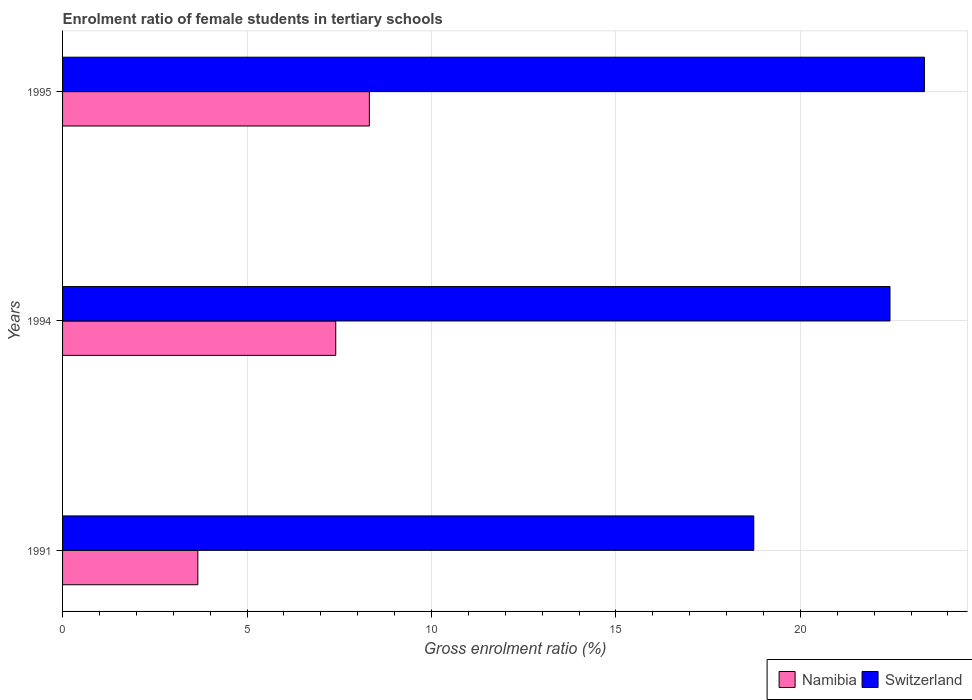How many different coloured bars are there?
Your answer should be very brief. 2. Are the number of bars per tick equal to the number of legend labels?
Your response must be concise. Yes. How many bars are there on the 3rd tick from the top?
Provide a succinct answer. 2. What is the enrolment ratio of female students in tertiary schools in Namibia in 1994?
Keep it short and to the point. 7.41. Across all years, what is the maximum enrolment ratio of female students in tertiary schools in Namibia?
Offer a terse response. 8.32. Across all years, what is the minimum enrolment ratio of female students in tertiary schools in Switzerland?
Your response must be concise. 18.74. What is the total enrolment ratio of female students in tertiary schools in Switzerland in the graph?
Provide a succinct answer. 64.53. What is the difference between the enrolment ratio of female students in tertiary schools in Switzerland in 1991 and that in 1994?
Make the answer very short. -3.69. What is the difference between the enrolment ratio of female students in tertiary schools in Switzerland in 1994 and the enrolment ratio of female students in tertiary schools in Namibia in 1995?
Make the answer very short. 14.11. What is the average enrolment ratio of female students in tertiary schools in Namibia per year?
Offer a terse response. 6.46. In the year 1991, what is the difference between the enrolment ratio of female students in tertiary schools in Namibia and enrolment ratio of female students in tertiary schools in Switzerland?
Your answer should be compact. -15.07. In how many years, is the enrolment ratio of female students in tertiary schools in Switzerland greater than 18 %?
Offer a terse response. 3. What is the ratio of the enrolment ratio of female students in tertiary schools in Namibia in 1991 to that in 1995?
Offer a terse response. 0.44. Is the difference between the enrolment ratio of female students in tertiary schools in Namibia in 1991 and 1995 greater than the difference between the enrolment ratio of female students in tertiary schools in Switzerland in 1991 and 1995?
Provide a short and direct response. No. What is the difference between the highest and the second highest enrolment ratio of female students in tertiary schools in Switzerland?
Give a very brief answer. 0.93. What is the difference between the highest and the lowest enrolment ratio of female students in tertiary schools in Switzerland?
Make the answer very short. 4.62. What does the 1st bar from the top in 1995 represents?
Keep it short and to the point. Switzerland. What does the 2nd bar from the bottom in 1991 represents?
Your answer should be very brief. Switzerland. How many bars are there?
Your answer should be compact. 6. How many years are there in the graph?
Your response must be concise. 3. Does the graph contain any zero values?
Offer a very short reply. No. Where does the legend appear in the graph?
Provide a succinct answer. Bottom right. How many legend labels are there?
Give a very brief answer. 2. What is the title of the graph?
Offer a terse response. Enrolment ratio of female students in tertiary schools. Does "Norway" appear as one of the legend labels in the graph?
Provide a succinct answer. No. What is the label or title of the Y-axis?
Your answer should be compact. Years. What is the Gross enrolment ratio (%) of Namibia in 1991?
Provide a short and direct response. 3.67. What is the Gross enrolment ratio (%) of Switzerland in 1991?
Your answer should be compact. 18.74. What is the Gross enrolment ratio (%) of Namibia in 1994?
Provide a short and direct response. 7.41. What is the Gross enrolment ratio (%) in Switzerland in 1994?
Your answer should be very brief. 22.43. What is the Gross enrolment ratio (%) in Namibia in 1995?
Keep it short and to the point. 8.32. What is the Gross enrolment ratio (%) of Switzerland in 1995?
Provide a succinct answer. 23.36. Across all years, what is the maximum Gross enrolment ratio (%) of Namibia?
Keep it short and to the point. 8.32. Across all years, what is the maximum Gross enrolment ratio (%) of Switzerland?
Give a very brief answer. 23.36. Across all years, what is the minimum Gross enrolment ratio (%) of Namibia?
Your answer should be compact. 3.67. Across all years, what is the minimum Gross enrolment ratio (%) in Switzerland?
Give a very brief answer. 18.74. What is the total Gross enrolment ratio (%) in Namibia in the graph?
Provide a succinct answer. 19.39. What is the total Gross enrolment ratio (%) in Switzerland in the graph?
Provide a short and direct response. 64.53. What is the difference between the Gross enrolment ratio (%) in Namibia in 1991 and that in 1994?
Your response must be concise. -3.74. What is the difference between the Gross enrolment ratio (%) of Switzerland in 1991 and that in 1994?
Give a very brief answer. -3.69. What is the difference between the Gross enrolment ratio (%) in Namibia in 1991 and that in 1995?
Your response must be concise. -4.65. What is the difference between the Gross enrolment ratio (%) of Switzerland in 1991 and that in 1995?
Make the answer very short. -4.62. What is the difference between the Gross enrolment ratio (%) of Namibia in 1994 and that in 1995?
Provide a short and direct response. -0.91. What is the difference between the Gross enrolment ratio (%) in Switzerland in 1994 and that in 1995?
Your answer should be compact. -0.93. What is the difference between the Gross enrolment ratio (%) in Namibia in 1991 and the Gross enrolment ratio (%) in Switzerland in 1994?
Give a very brief answer. -18.76. What is the difference between the Gross enrolment ratio (%) of Namibia in 1991 and the Gross enrolment ratio (%) of Switzerland in 1995?
Make the answer very short. -19.7. What is the difference between the Gross enrolment ratio (%) in Namibia in 1994 and the Gross enrolment ratio (%) in Switzerland in 1995?
Offer a very short reply. -15.96. What is the average Gross enrolment ratio (%) of Namibia per year?
Make the answer very short. 6.46. What is the average Gross enrolment ratio (%) of Switzerland per year?
Provide a succinct answer. 21.51. In the year 1991, what is the difference between the Gross enrolment ratio (%) in Namibia and Gross enrolment ratio (%) in Switzerland?
Make the answer very short. -15.07. In the year 1994, what is the difference between the Gross enrolment ratio (%) in Namibia and Gross enrolment ratio (%) in Switzerland?
Provide a succinct answer. -15.02. In the year 1995, what is the difference between the Gross enrolment ratio (%) of Namibia and Gross enrolment ratio (%) of Switzerland?
Offer a very short reply. -15.05. What is the ratio of the Gross enrolment ratio (%) of Namibia in 1991 to that in 1994?
Ensure brevity in your answer.  0.5. What is the ratio of the Gross enrolment ratio (%) in Switzerland in 1991 to that in 1994?
Offer a terse response. 0.84. What is the ratio of the Gross enrolment ratio (%) of Namibia in 1991 to that in 1995?
Your response must be concise. 0.44. What is the ratio of the Gross enrolment ratio (%) of Switzerland in 1991 to that in 1995?
Give a very brief answer. 0.8. What is the ratio of the Gross enrolment ratio (%) of Namibia in 1994 to that in 1995?
Your response must be concise. 0.89. What is the ratio of the Gross enrolment ratio (%) in Switzerland in 1994 to that in 1995?
Ensure brevity in your answer.  0.96. What is the difference between the highest and the second highest Gross enrolment ratio (%) in Namibia?
Make the answer very short. 0.91. What is the difference between the highest and the second highest Gross enrolment ratio (%) of Switzerland?
Keep it short and to the point. 0.93. What is the difference between the highest and the lowest Gross enrolment ratio (%) of Namibia?
Provide a short and direct response. 4.65. What is the difference between the highest and the lowest Gross enrolment ratio (%) of Switzerland?
Offer a very short reply. 4.62. 